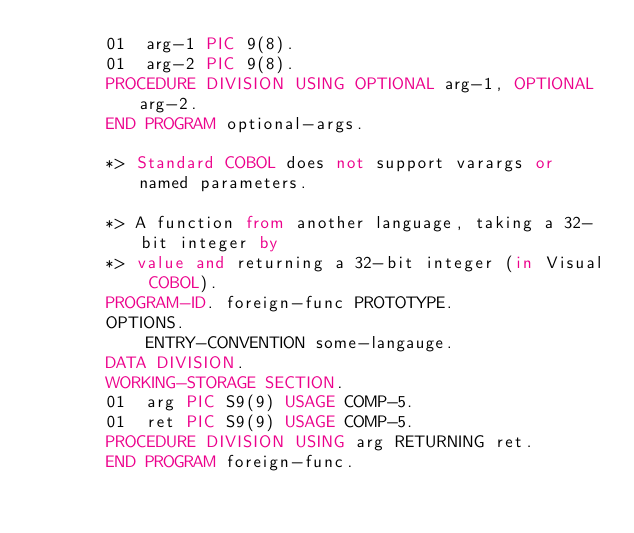Convert code to text. <code><loc_0><loc_0><loc_500><loc_500><_COBOL_>       01  arg-1 PIC 9(8).
       01  arg-2 PIC 9(8).
       PROCEDURE DIVISION USING OPTIONAL arg-1, OPTIONAL arg-2.
       END PROGRAM optional-args.

       *> Standard COBOL does not support varargs or named parameters.

       *> A function from another language, taking a 32-bit integer by
       *> value and returning a 32-bit integer (in Visual COBOL).
       PROGRAM-ID. foreign-func PROTOTYPE.
       OPTIONS.
           ENTRY-CONVENTION some-langauge.
       DATA DIVISION.
       WORKING-STORAGE SECTION.
       01  arg PIC S9(9) USAGE COMP-5.
       01  ret PIC S9(9) USAGE COMP-5.
       PROCEDURE DIVISION USING arg RETURNING ret.
       END PROGRAM foreign-func.
</code> 